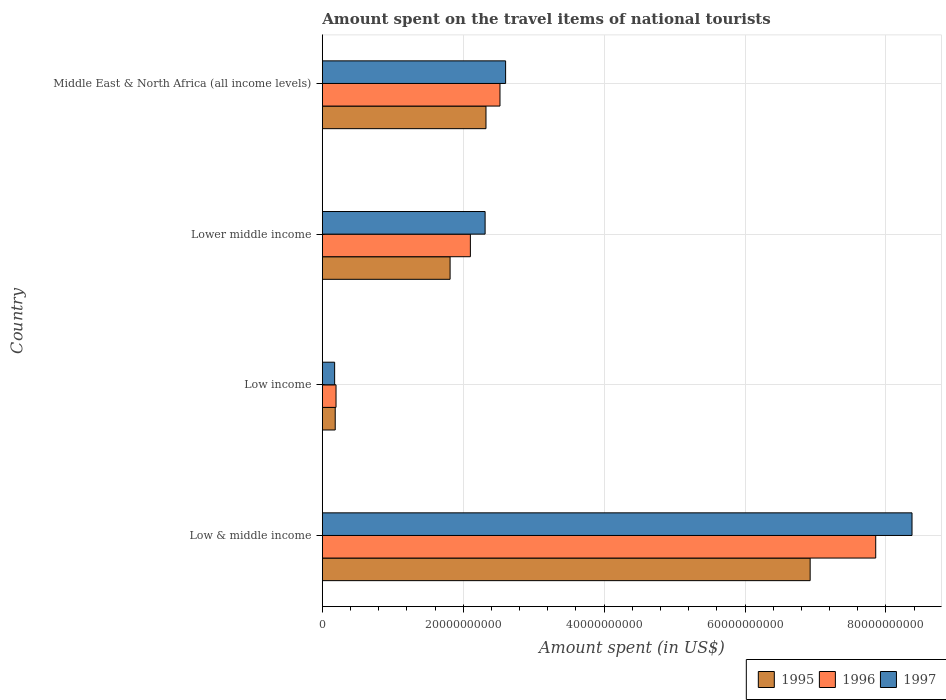How many different coloured bars are there?
Ensure brevity in your answer.  3. How many groups of bars are there?
Your answer should be very brief. 4. Are the number of bars on each tick of the Y-axis equal?
Ensure brevity in your answer.  Yes. What is the label of the 1st group of bars from the top?
Offer a terse response. Middle East & North Africa (all income levels). What is the amount spent on the travel items of national tourists in 1995 in Low & middle income?
Give a very brief answer. 6.92e+1. Across all countries, what is the maximum amount spent on the travel items of national tourists in 1995?
Your answer should be very brief. 6.92e+1. Across all countries, what is the minimum amount spent on the travel items of national tourists in 1997?
Your answer should be compact. 1.75e+09. In which country was the amount spent on the travel items of national tourists in 1996 maximum?
Give a very brief answer. Low & middle income. What is the total amount spent on the travel items of national tourists in 1995 in the graph?
Make the answer very short. 1.12e+11. What is the difference between the amount spent on the travel items of national tourists in 1996 in Low & middle income and that in Middle East & North Africa (all income levels)?
Offer a very short reply. 5.33e+1. What is the difference between the amount spent on the travel items of national tourists in 1997 in Low & middle income and the amount spent on the travel items of national tourists in 1996 in Low income?
Your answer should be very brief. 8.18e+1. What is the average amount spent on the travel items of national tourists in 1996 per country?
Your answer should be compact. 3.17e+1. What is the difference between the amount spent on the travel items of national tourists in 1996 and amount spent on the travel items of national tourists in 1997 in Middle East & North Africa (all income levels)?
Your answer should be compact. -7.97e+08. What is the ratio of the amount spent on the travel items of national tourists in 1997 in Low & middle income to that in Lower middle income?
Give a very brief answer. 3.62. Is the amount spent on the travel items of national tourists in 1997 in Low income less than that in Middle East & North Africa (all income levels)?
Provide a short and direct response. Yes. What is the difference between the highest and the second highest amount spent on the travel items of national tourists in 1997?
Provide a short and direct response. 5.77e+1. What is the difference between the highest and the lowest amount spent on the travel items of national tourists in 1996?
Offer a very short reply. 7.66e+1. In how many countries, is the amount spent on the travel items of national tourists in 1996 greater than the average amount spent on the travel items of national tourists in 1996 taken over all countries?
Give a very brief answer. 1. What does the 2nd bar from the bottom in Low income represents?
Provide a short and direct response. 1996. Is it the case that in every country, the sum of the amount spent on the travel items of national tourists in 1996 and amount spent on the travel items of national tourists in 1995 is greater than the amount spent on the travel items of national tourists in 1997?
Give a very brief answer. Yes. How many countries are there in the graph?
Offer a terse response. 4. Are the values on the major ticks of X-axis written in scientific E-notation?
Keep it short and to the point. No. Does the graph contain any zero values?
Offer a terse response. No. Does the graph contain grids?
Your answer should be compact. Yes. Where does the legend appear in the graph?
Offer a very short reply. Bottom right. What is the title of the graph?
Your answer should be compact. Amount spent on the travel items of national tourists. What is the label or title of the X-axis?
Ensure brevity in your answer.  Amount spent (in US$). What is the Amount spent (in US$) in 1995 in Low & middle income?
Your response must be concise. 6.92e+1. What is the Amount spent (in US$) of 1996 in Low & middle income?
Ensure brevity in your answer.  7.85e+1. What is the Amount spent (in US$) in 1997 in Low & middle income?
Your answer should be compact. 8.37e+1. What is the Amount spent (in US$) of 1995 in Low income?
Make the answer very short. 1.83e+09. What is the Amount spent (in US$) of 1996 in Low income?
Provide a succinct answer. 1.94e+09. What is the Amount spent (in US$) of 1997 in Low income?
Your answer should be very brief. 1.75e+09. What is the Amount spent (in US$) in 1995 in Lower middle income?
Your answer should be compact. 1.81e+1. What is the Amount spent (in US$) in 1996 in Lower middle income?
Offer a very short reply. 2.10e+1. What is the Amount spent (in US$) in 1997 in Lower middle income?
Provide a succinct answer. 2.31e+1. What is the Amount spent (in US$) of 1995 in Middle East & North Africa (all income levels)?
Provide a succinct answer. 2.32e+1. What is the Amount spent (in US$) in 1996 in Middle East & North Africa (all income levels)?
Ensure brevity in your answer.  2.52e+1. What is the Amount spent (in US$) in 1997 in Middle East & North Africa (all income levels)?
Offer a very short reply. 2.60e+1. Across all countries, what is the maximum Amount spent (in US$) in 1995?
Give a very brief answer. 6.92e+1. Across all countries, what is the maximum Amount spent (in US$) of 1996?
Give a very brief answer. 7.85e+1. Across all countries, what is the maximum Amount spent (in US$) in 1997?
Your response must be concise. 8.37e+1. Across all countries, what is the minimum Amount spent (in US$) of 1995?
Give a very brief answer. 1.83e+09. Across all countries, what is the minimum Amount spent (in US$) of 1996?
Your answer should be very brief. 1.94e+09. Across all countries, what is the minimum Amount spent (in US$) in 1997?
Give a very brief answer. 1.75e+09. What is the total Amount spent (in US$) in 1995 in the graph?
Give a very brief answer. 1.12e+11. What is the total Amount spent (in US$) in 1996 in the graph?
Make the answer very short. 1.27e+11. What is the total Amount spent (in US$) in 1997 in the graph?
Provide a succinct answer. 1.35e+11. What is the difference between the Amount spent (in US$) of 1995 in Low & middle income and that in Low income?
Keep it short and to the point. 6.74e+1. What is the difference between the Amount spent (in US$) in 1996 in Low & middle income and that in Low income?
Make the answer very short. 7.66e+1. What is the difference between the Amount spent (in US$) of 1997 in Low & middle income and that in Low income?
Give a very brief answer. 8.19e+1. What is the difference between the Amount spent (in US$) of 1995 in Low & middle income and that in Lower middle income?
Your response must be concise. 5.11e+1. What is the difference between the Amount spent (in US$) in 1996 in Low & middle income and that in Lower middle income?
Offer a very short reply. 5.75e+1. What is the difference between the Amount spent (in US$) of 1997 in Low & middle income and that in Lower middle income?
Make the answer very short. 6.06e+1. What is the difference between the Amount spent (in US$) of 1995 in Low & middle income and that in Middle East & North Africa (all income levels)?
Offer a terse response. 4.60e+1. What is the difference between the Amount spent (in US$) in 1996 in Low & middle income and that in Middle East & North Africa (all income levels)?
Your answer should be compact. 5.33e+1. What is the difference between the Amount spent (in US$) in 1997 in Low & middle income and that in Middle East & North Africa (all income levels)?
Your response must be concise. 5.77e+1. What is the difference between the Amount spent (in US$) of 1995 in Low income and that in Lower middle income?
Give a very brief answer. -1.63e+1. What is the difference between the Amount spent (in US$) of 1996 in Low income and that in Lower middle income?
Make the answer very short. -1.91e+1. What is the difference between the Amount spent (in US$) in 1997 in Low income and that in Lower middle income?
Your response must be concise. -2.14e+1. What is the difference between the Amount spent (in US$) in 1995 in Low income and that in Middle East & North Africa (all income levels)?
Offer a terse response. -2.14e+1. What is the difference between the Amount spent (in US$) in 1996 in Low income and that in Middle East & North Africa (all income levels)?
Give a very brief answer. -2.33e+1. What is the difference between the Amount spent (in US$) in 1997 in Low income and that in Middle East & North Africa (all income levels)?
Offer a terse response. -2.43e+1. What is the difference between the Amount spent (in US$) of 1995 in Lower middle income and that in Middle East & North Africa (all income levels)?
Your response must be concise. -5.09e+09. What is the difference between the Amount spent (in US$) in 1996 in Lower middle income and that in Middle East & North Africa (all income levels)?
Your answer should be compact. -4.20e+09. What is the difference between the Amount spent (in US$) in 1997 in Lower middle income and that in Middle East & North Africa (all income levels)?
Ensure brevity in your answer.  -2.91e+09. What is the difference between the Amount spent (in US$) of 1995 in Low & middle income and the Amount spent (in US$) of 1996 in Low income?
Provide a short and direct response. 6.73e+1. What is the difference between the Amount spent (in US$) of 1995 in Low & middle income and the Amount spent (in US$) of 1997 in Low income?
Your answer should be compact. 6.75e+1. What is the difference between the Amount spent (in US$) in 1996 in Low & middle income and the Amount spent (in US$) in 1997 in Low income?
Ensure brevity in your answer.  7.68e+1. What is the difference between the Amount spent (in US$) in 1995 in Low & middle income and the Amount spent (in US$) in 1996 in Lower middle income?
Provide a short and direct response. 4.82e+1. What is the difference between the Amount spent (in US$) of 1995 in Low & middle income and the Amount spent (in US$) of 1997 in Lower middle income?
Provide a short and direct response. 4.61e+1. What is the difference between the Amount spent (in US$) of 1996 in Low & middle income and the Amount spent (in US$) of 1997 in Lower middle income?
Offer a very short reply. 5.54e+1. What is the difference between the Amount spent (in US$) in 1995 in Low & middle income and the Amount spent (in US$) in 1996 in Middle East & North Africa (all income levels)?
Make the answer very short. 4.40e+1. What is the difference between the Amount spent (in US$) of 1995 in Low & middle income and the Amount spent (in US$) of 1997 in Middle East & North Africa (all income levels)?
Your answer should be compact. 4.32e+1. What is the difference between the Amount spent (in US$) of 1996 in Low & middle income and the Amount spent (in US$) of 1997 in Middle East & North Africa (all income levels)?
Provide a short and direct response. 5.25e+1. What is the difference between the Amount spent (in US$) in 1995 in Low income and the Amount spent (in US$) in 1996 in Lower middle income?
Offer a terse response. -1.92e+1. What is the difference between the Amount spent (in US$) of 1995 in Low income and the Amount spent (in US$) of 1997 in Lower middle income?
Offer a terse response. -2.13e+1. What is the difference between the Amount spent (in US$) in 1996 in Low income and the Amount spent (in US$) in 1997 in Lower middle income?
Your response must be concise. -2.12e+1. What is the difference between the Amount spent (in US$) of 1995 in Low income and the Amount spent (in US$) of 1996 in Middle East & North Africa (all income levels)?
Provide a short and direct response. -2.34e+1. What is the difference between the Amount spent (in US$) in 1995 in Low income and the Amount spent (in US$) in 1997 in Middle East & North Africa (all income levels)?
Give a very brief answer. -2.42e+1. What is the difference between the Amount spent (in US$) in 1996 in Low income and the Amount spent (in US$) in 1997 in Middle East & North Africa (all income levels)?
Offer a terse response. -2.41e+1. What is the difference between the Amount spent (in US$) of 1995 in Lower middle income and the Amount spent (in US$) of 1996 in Middle East & North Africa (all income levels)?
Provide a short and direct response. -7.08e+09. What is the difference between the Amount spent (in US$) in 1995 in Lower middle income and the Amount spent (in US$) in 1997 in Middle East & North Africa (all income levels)?
Offer a very short reply. -7.88e+09. What is the difference between the Amount spent (in US$) in 1996 in Lower middle income and the Amount spent (in US$) in 1997 in Middle East & North Africa (all income levels)?
Provide a succinct answer. -5.00e+09. What is the average Amount spent (in US$) in 1995 per country?
Your response must be concise. 2.81e+1. What is the average Amount spent (in US$) in 1996 per country?
Your answer should be compact. 3.17e+1. What is the average Amount spent (in US$) in 1997 per country?
Keep it short and to the point. 3.36e+1. What is the difference between the Amount spent (in US$) of 1995 and Amount spent (in US$) of 1996 in Low & middle income?
Ensure brevity in your answer.  -9.31e+09. What is the difference between the Amount spent (in US$) of 1995 and Amount spent (in US$) of 1997 in Low & middle income?
Give a very brief answer. -1.45e+1. What is the difference between the Amount spent (in US$) in 1996 and Amount spent (in US$) in 1997 in Low & middle income?
Provide a succinct answer. -5.15e+09. What is the difference between the Amount spent (in US$) in 1995 and Amount spent (in US$) in 1996 in Low income?
Provide a short and direct response. -1.15e+08. What is the difference between the Amount spent (in US$) in 1995 and Amount spent (in US$) in 1997 in Low income?
Keep it short and to the point. 8.10e+07. What is the difference between the Amount spent (in US$) of 1996 and Amount spent (in US$) of 1997 in Low income?
Your response must be concise. 1.96e+08. What is the difference between the Amount spent (in US$) in 1995 and Amount spent (in US$) in 1996 in Lower middle income?
Make the answer very short. -2.88e+09. What is the difference between the Amount spent (in US$) in 1995 and Amount spent (in US$) in 1997 in Lower middle income?
Your answer should be very brief. -4.97e+09. What is the difference between the Amount spent (in US$) of 1996 and Amount spent (in US$) of 1997 in Lower middle income?
Provide a succinct answer. -2.09e+09. What is the difference between the Amount spent (in US$) in 1995 and Amount spent (in US$) in 1996 in Middle East & North Africa (all income levels)?
Ensure brevity in your answer.  -1.99e+09. What is the difference between the Amount spent (in US$) in 1995 and Amount spent (in US$) in 1997 in Middle East & North Africa (all income levels)?
Offer a very short reply. -2.79e+09. What is the difference between the Amount spent (in US$) of 1996 and Amount spent (in US$) of 1997 in Middle East & North Africa (all income levels)?
Your answer should be very brief. -7.97e+08. What is the ratio of the Amount spent (in US$) in 1995 in Low & middle income to that in Low income?
Your response must be concise. 37.85. What is the ratio of the Amount spent (in US$) in 1996 in Low & middle income to that in Low income?
Offer a very short reply. 40.39. What is the ratio of the Amount spent (in US$) in 1997 in Low & middle income to that in Low income?
Provide a succinct answer. 47.87. What is the ratio of the Amount spent (in US$) of 1995 in Low & middle income to that in Lower middle income?
Give a very brief answer. 3.82. What is the ratio of the Amount spent (in US$) of 1996 in Low & middle income to that in Lower middle income?
Your answer should be very brief. 3.74. What is the ratio of the Amount spent (in US$) in 1997 in Low & middle income to that in Lower middle income?
Your answer should be very brief. 3.62. What is the ratio of the Amount spent (in US$) in 1995 in Low & middle income to that in Middle East & North Africa (all income levels)?
Make the answer very short. 2.98. What is the ratio of the Amount spent (in US$) in 1996 in Low & middle income to that in Middle East & North Africa (all income levels)?
Make the answer very short. 3.12. What is the ratio of the Amount spent (in US$) in 1997 in Low & middle income to that in Middle East & North Africa (all income levels)?
Your response must be concise. 3.22. What is the ratio of the Amount spent (in US$) in 1995 in Low income to that in Lower middle income?
Give a very brief answer. 0.1. What is the ratio of the Amount spent (in US$) of 1996 in Low income to that in Lower middle income?
Provide a short and direct response. 0.09. What is the ratio of the Amount spent (in US$) in 1997 in Low income to that in Lower middle income?
Offer a very short reply. 0.08. What is the ratio of the Amount spent (in US$) in 1995 in Low income to that in Middle East & North Africa (all income levels)?
Ensure brevity in your answer.  0.08. What is the ratio of the Amount spent (in US$) in 1996 in Low income to that in Middle East & North Africa (all income levels)?
Your answer should be compact. 0.08. What is the ratio of the Amount spent (in US$) of 1997 in Low income to that in Middle East & North Africa (all income levels)?
Your answer should be compact. 0.07. What is the ratio of the Amount spent (in US$) of 1995 in Lower middle income to that in Middle East & North Africa (all income levels)?
Make the answer very short. 0.78. What is the ratio of the Amount spent (in US$) of 1997 in Lower middle income to that in Middle East & North Africa (all income levels)?
Your response must be concise. 0.89. What is the difference between the highest and the second highest Amount spent (in US$) of 1995?
Give a very brief answer. 4.60e+1. What is the difference between the highest and the second highest Amount spent (in US$) of 1996?
Ensure brevity in your answer.  5.33e+1. What is the difference between the highest and the second highest Amount spent (in US$) in 1997?
Offer a very short reply. 5.77e+1. What is the difference between the highest and the lowest Amount spent (in US$) in 1995?
Ensure brevity in your answer.  6.74e+1. What is the difference between the highest and the lowest Amount spent (in US$) of 1996?
Offer a very short reply. 7.66e+1. What is the difference between the highest and the lowest Amount spent (in US$) of 1997?
Offer a terse response. 8.19e+1. 